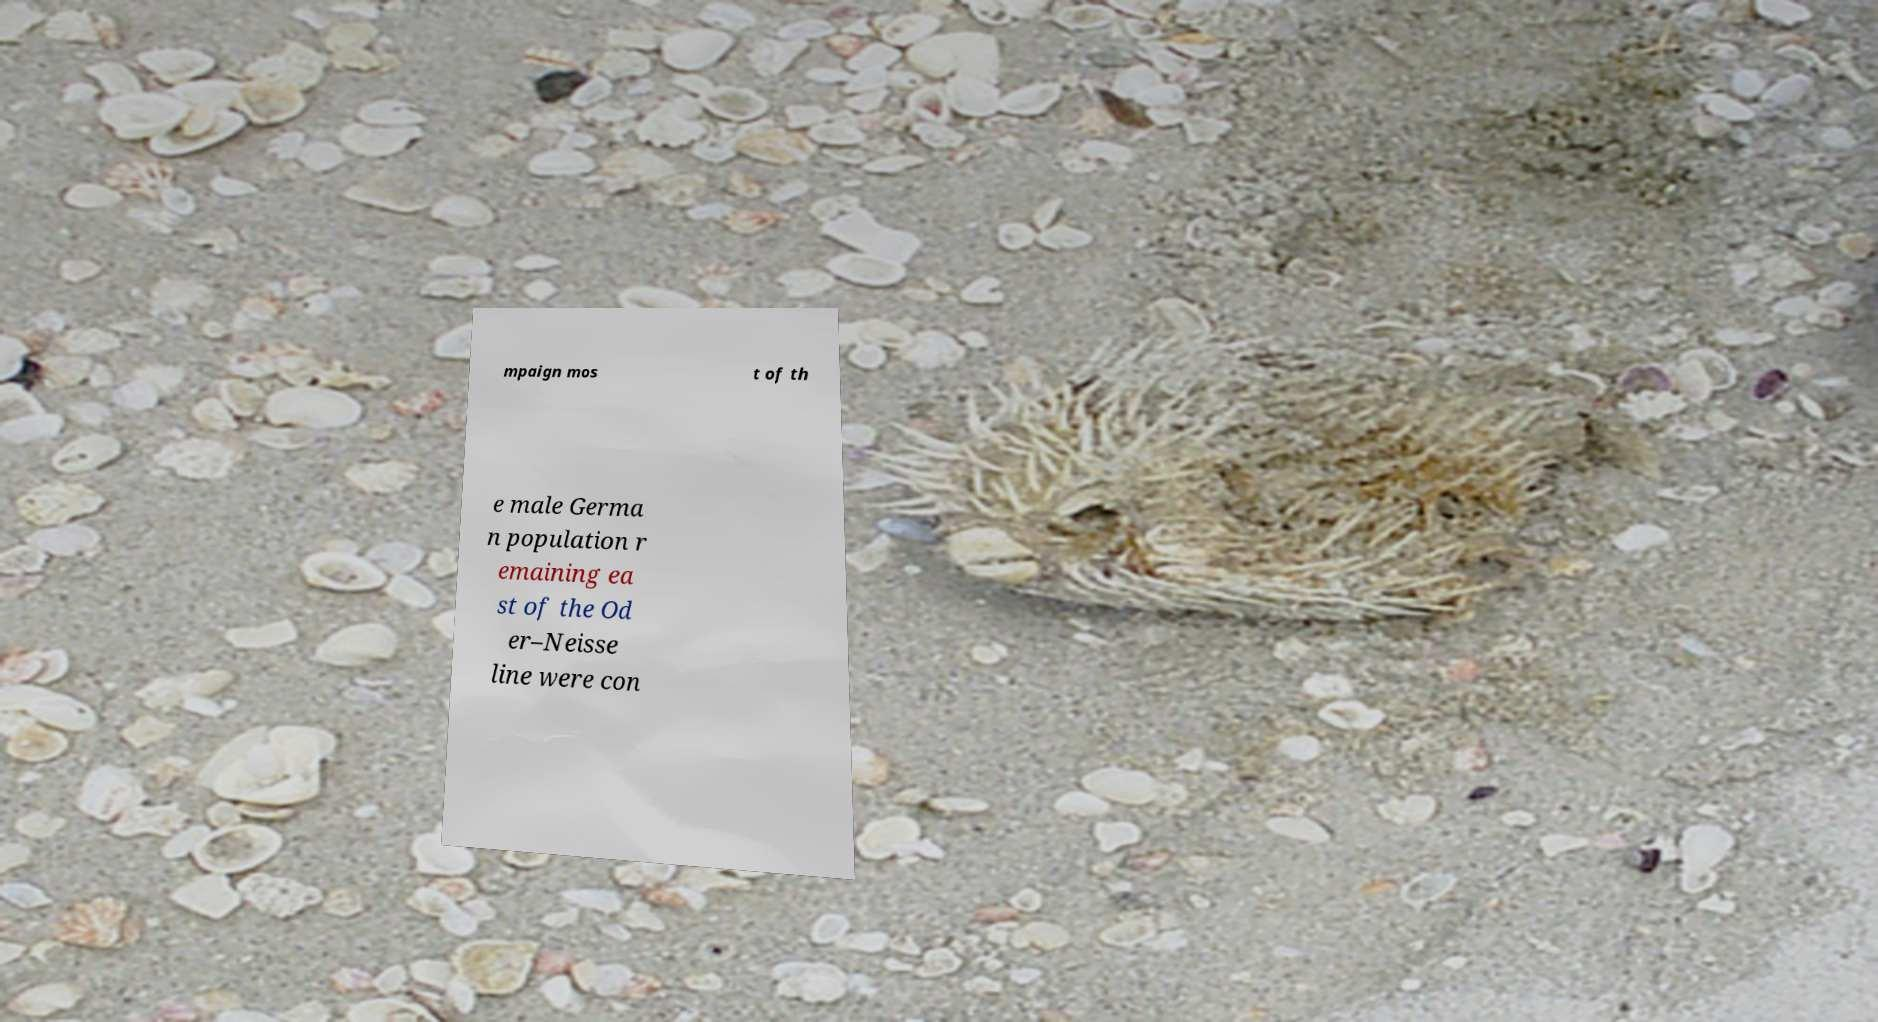Can you accurately transcribe the text from the provided image for me? mpaign mos t of th e male Germa n population r emaining ea st of the Od er–Neisse line were con 